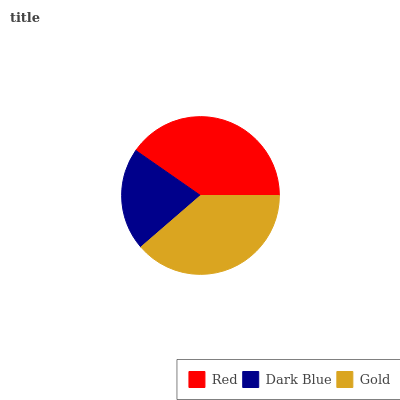Is Dark Blue the minimum?
Answer yes or no. Yes. Is Red the maximum?
Answer yes or no. Yes. Is Gold the minimum?
Answer yes or no. No. Is Gold the maximum?
Answer yes or no. No. Is Gold greater than Dark Blue?
Answer yes or no. Yes. Is Dark Blue less than Gold?
Answer yes or no. Yes. Is Dark Blue greater than Gold?
Answer yes or no. No. Is Gold less than Dark Blue?
Answer yes or no. No. Is Gold the high median?
Answer yes or no. Yes. Is Gold the low median?
Answer yes or no. Yes. Is Red the high median?
Answer yes or no. No. Is Red the low median?
Answer yes or no. No. 